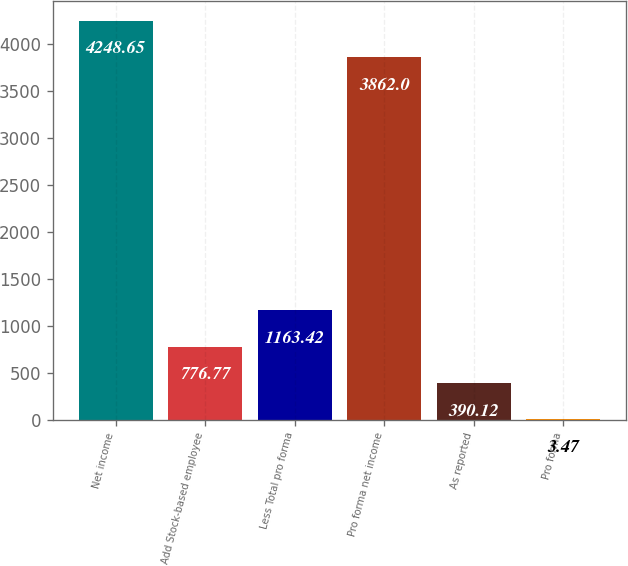Convert chart. <chart><loc_0><loc_0><loc_500><loc_500><bar_chart><fcel>Net income<fcel>Add Stock-based employee<fcel>Less Total pro forma<fcel>Pro forma net income<fcel>As reported<fcel>Pro forma<nl><fcel>4248.65<fcel>776.77<fcel>1163.42<fcel>3862<fcel>390.12<fcel>3.47<nl></chart> 